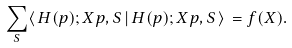Convert formula to latex. <formula><loc_0><loc_0><loc_500><loc_500>\sum _ { S } \langle \, H ( p ) ; X p , S \, | \, H ( p ) ; X p , S \, \rangle \, = f ( X ) .</formula> 